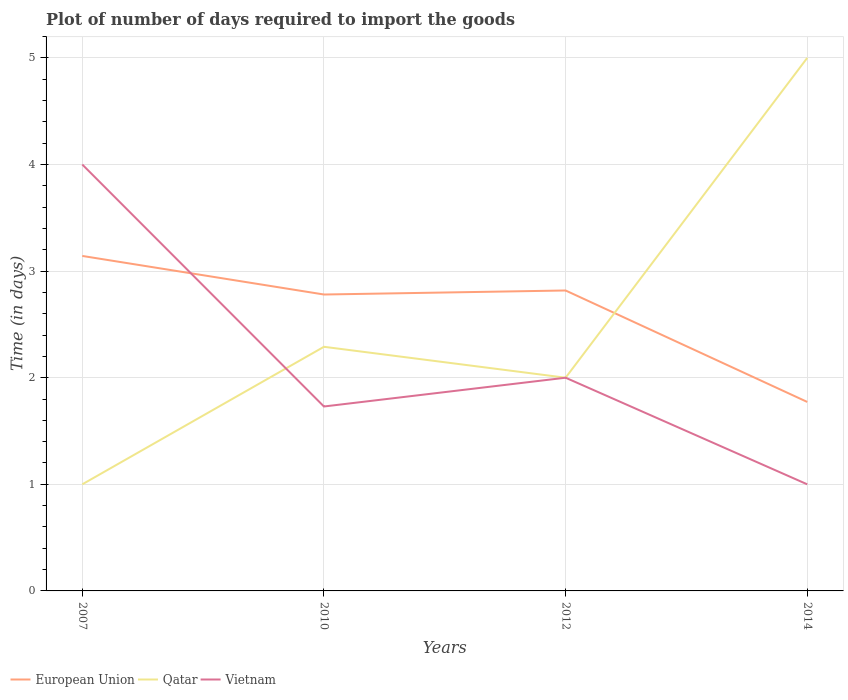Is the number of lines equal to the number of legend labels?
Give a very brief answer. Yes. Across all years, what is the maximum time required to import goods in Qatar?
Your answer should be compact. 1. In which year was the time required to import goods in Qatar maximum?
Offer a terse response. 2007. What is the total time required to import goods in European Union in the graph?
Provide a succinct answer. 0.36. Is the time required to import goods in European Union strictly greater than the time required to import goods in Qatar over the years?
Your answer should be compact. No. Does the graph contain any zero values?
Your answer should be compact. No. Does the graph contain grids?
Your answer should be very brief. Yes. How many legend labels are there?
Offer a terse response. 3. What is the title of the graph?
Ensure brevity in your answer.  Plot of number of days required to import the goods. What is the label or title of the X-axis?
Make the answer very short. Years. What is the label or title of the Y-axis?
Make the answer very short. Time (in days). What is the Time (in days) of European Union in 2007?
Offer a terse response. 3.14. What is the Time (in days) in European Union in 2010?
Make the answer very short. 2.78. What is the Time (in days) in Qatar in 2010?
Offer a very short reply. 2.29. What is the Time (in days) in Vietnam in 2010?
Your response must be concise. 1.73. What is the Time (in days) of European Union in 2012?
Give a very brief answer. 2.82. What is the Time (in days) in Qatar in 2012?
Ensure brevity in your answer.  2. What is the Time (in days) of Vietnam in 2012?
Offer a very short reply. 2. What is the Time (in days) of European Union in 2014?
Give a very brief answer. 1.77. What is the Time (in days) in Vietnam in 2014?
Provide a short and direct response. 1. Across all years, what is the maximum Time (in days) of European Union?
Offer a very short reply. 3.14. Across all years, what is the minimum Time (in days) of European Union?
Provide a short and direct response. 1.77. Across all years, what is the minimum Time (in days) of Qatar?
Provide a short and direct response. 1. Across all years, what is the minimum Time (in days) of Vietnam?
Give a very brief answer. 1. What is the total Time (in days) in European Union in the graph?
Make the answer very short. 10.51. What is the total Time (in days) of Qatar in the graph?
Offer a terse response. 10.29. What is the total Time (in days) of Vietnam in the graph?
Your answer should be compact. 8.73. What is the difference between the Time (in days) in European Union in 2007 and that in 2010?
Provide a short and direct response. 0.36. What is the difference between the Time (in days) of Qatar in 2007 and that in 2010?
Your answer should be very brief. -1.29. What is the difference between the Time (in days) in Vietnam in 2007 and that in 2010?
Give a very brief answer. 2.27. What is the difference between the Time (in days) in European Union in 2007 and that in 2012?
Offer a very short reply. 0.32. What is the difference between the Time (in days) in Vietnam in 2007 and that in 2012?
Provide a succinct answer. 2. What is the difference between the Time (in days) of European Union in 2007 and that in 2014?
Ensure brevity in your answer.  1.37. What is the difference between the Time (in days) in European Union in 2010 and that in 2012?
Make the answer very short. -0.04. What is the difference between the Time (in days) of Qatar in 2010 and that in 2012?
Your response must be concise. 0.29. What is the difference between the Time (in days) of Vietnam in 2010 and that in 2012?
Provide a succinct answer. -0.27. What is the difference between the Time (in days) of European Union in 2010 and that in 2014?
Keep it short and to the point. 1.01. What is the difference between the Time (in days) in Qatar in 2010 and that in 2014?
Offer a very short reply. -2.71. What is the difference between the Time (in days) in Vietnam in 2010 and that in 2014?
Make the answer very short. 0.73. What is the difference between the Time (in days) of European Union in 2012 and that in 2014?
Your answer should be compact. 1.05. What is the difference between the Time (in days) of Qatar in 2012 and that in 2014?
Your response must be concise. -3. What is the difference between the Time (in days) of European Union in 2007 and the Time (in days) of Qatar in 2010?
Your answer should be compact. 0.85. What is the difference between the Time (in days) of European Union in 2007 and the Time (in days) of Vietnam in 2010?
Your response must be concise. 1.41. What is the difference between the Time (in days) in Qatar in 2007 and the Time (in days) in Vietnam in 2010?
Provide a short and direct response. -0.73. What is the difference between the Time (in days) in European Union in 2007 and the Time (in days) in Qatar in 2012?
Give a very brief answer. 1.14. What is the difference between the Time (in days) in European Union in 2007 and the Time (in days) in Vietnam in 2012?
Ensure brevity in your answer.  1.14. What is the difference between the Time (in days) in Qatar in 2007 and the Time (in days) in Vietnam in 2012?
Your response must be concise. -1. What is the difference between the Time (in days) in European Union in 2007 and the Time (in days) in Qatar in 2014?
Give a very brief answer. -1.86. What is the difference between the Time (in days) of European Union in 2007 and the Time (in days) of Vietnam in 2014?
Provide a succinct answer. 2.14. What is the difference between the Time (in days) in Qatar in 2007 and the Time (in days) in Vietnam in 2014?
Give a very brief answer. 0. What is the difference between the Time (in days) of European Union in 2010 and the Time (in days) of Qatar in 2012?
Offer a very short reply. 0.78. What is the difference between the Time (in days) of European Union in 2010 and the Time (in days) of Vietnam in 2012?
Give a very brief answer. 0.78. What is the difference between the Time (in days) in Qatar in 2010 and the Time (in days) in Vietnam in 2012?
Offer a very short reply. 0.29. What is the difference between the Time (in days) of European Union in 2010 and the Time (in days) of Qatar in 2014?
Offer a very short reply. -2.22. What is the difference between the Time (in days) in European Union in 2010 and the Time (in days) in Vietnam in 2014?
Offer a very short reply. 1.78. What is the difference between the Time (in days) of Qatar in 2010 and the Time (in days) of Vietnam in 2014?
Your answer should be very brief. 1.29. What is the difference between the Time (in days) in European Union in 2012 and the Time (in days) in Qatar in 2014?
Offer a terse response. -2.18. What is the difference between the Time (in days) of European Union in 2012 and the Time (in days) of Vietnam in 2014?
Your response must be concise. 1.82. What is the difference between the Time (in days) in Qatar in 2012 and the Time (in days) in Vietnam in 2014?
Offer a terse response. 1. What is the average Time (in days) of European Union per year?
Give a very brief answer. 2.63. What is the average Time (in days) of Qatar per year?
Provide a succinct answer. 2.57. What is the average Time (in days) in Vietnam per year?
Give a very brief answer. 2.18. In the year 2007, what is the difference between the Time (in days) of European Union and Time (in days) of Qatar?
Keep it short and to the point. 2.14. In the year 2007, what is the difference between the Time (in days) in European Union and Time (in days) in Vietnam?
Keep it short and to the point. -0.86. In the year 2010, what is the difference between the Time (in days) of European Union and Time (in days) of Qatar?
Provide a short and direct response. 0.49. In the year 2010, what is the difference between the Time (in days) in European Union and Time (in days) in Vietnam?
Offer a terse response. 1.05. In the year 2010, what is the difference between the Time (in days) of Qatar and Time (in days) of Vietnam?
Give a very brief answer. 0.56. In the year 2012, what is the difference between the Time (in days) in European Union and Time (in days) in Qatar?
Offer a very short reply. 0.82. In the year 2012, what is the difference between the Time (in days) in European Union and Time (in days) in Vietnam?
Offer a terse response. 0.82. In the year 2012, what is the difference between the Time (in days) in Qatar and Time (in days) in Vietnam?
Give a very brief answer. 0. In the year 2014, what is the difference between the Time (in days) of European Union and Time (in days) of Qatar?
Your response must be concise. -3.23. In the year 2014, what is the difference between the Time (in days) of European Union and Time (in days) of Vietnam?
Your response must be concise. 0.77. What is the ratio of the Time (in days) of European Union in 2007 to that in 2010?
Provide a short and direct response. 1.13. What is the ratio of the Time (in days) in Qatar in 2007 to that in 2010?
Provide a short and direct response. 0.44. What is the ratio of the Time (in days) in Vietnam in 2007 to that in 2010?
Provide a succinct answer. 2.31. What is the ratio of the Time (in days) in European Union in 2007 to that in 2012?
Make the answer very short. 1.11. What is the ratio of the Time (in days) in Qatar in 2007 to that in 2012?
Give a very brief answer. 0.5. What is the ratio of the Time (in days) in Vietnam in 2007 to that in 2012?
Offer a terse response. 2. What is the ratio of the Time (in days) in European Union in 2007 to that in 2014?
Offer a very short reply. 1.77. What is the ratio of the Time (in days) in European Union in 2010 to that in 2012?
Keep it short and to the point. 0.99. What is the ratio of the Time (in days) of Qatar in 2010 to that in 2012?
Provide a short and direct response. 1.15. What is the ratio of the Time (in days) in Vietnam in 2010 to that in 2012?
Ensure brevity in your answer.  0.86. What is the ratio of the Time (in days) of European Union in 2010 to that in 2014?
Provide a short and direct response. 1.57. What is the ratio of the Time (in days) in Qatar in 2010 to that in 2014?
Make the answer very short. 0.46. What is the ratio of the Time (in days) of Vietnam in 2010 to that in 2014?
Your answer should be very brief. 1.73. What is the ratio of the Time (in days) in European Union in 2012 to that in 2014?
Provide a succinct answer. 1.59. What is the difference between the highest and the second highest Time (in days) of European Union?
Your response must be concise. 0.32. What is the difference between the highest and the second highest Time (in days) in Qatar?
Make the answer very short. 2.71. What is the difference between the highest and the lowest Time (in days) in European Union?
Your response must be concise. 1.37. What is the difference between the highest and the lowest Time (in days) in Qatar?
Keep it short and to the point. 4. 